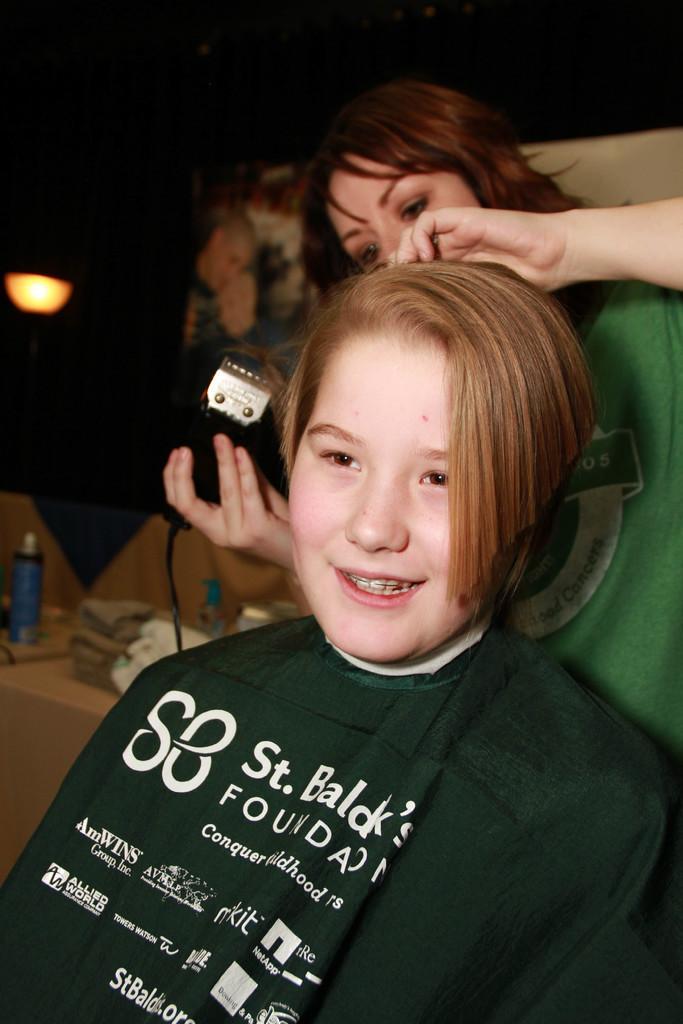Describe this image in one or two sentences. In this image there is a girl, behind the girl there is another girl standing and holding some object in her hand and doing something with the hair of the girl. On the left side of the image we can see there are a few objects are placed on the rack. The background is dark. 